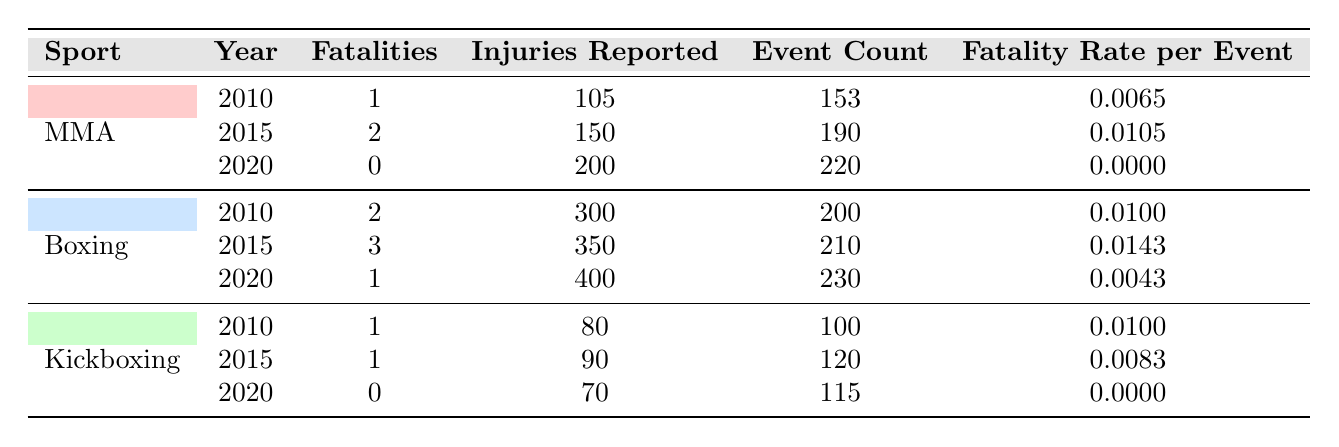What were the total fatalities in MMA between 2010 and 2020? Adding up the fatalities for the years 2010 (1), 2015 (2), and 2020 (0) gives a total of 3 fatalities in MMA over this period.
Answer: 3 In which year did MMA have the highest fatality rate per event? Looking at the fatality rates per event for MMA, in 2015 it was 0.0105, which is higher than the rates for 2010 (0.0065) and 2020 (0.0000). Thus, 2015 had the highest fatality rate.
Answer: 2015 Did boxing have more injury-related fatalities than MMA in 2010? In 2010, boxing had 2 fatalities while MMA had 1 fatality. Therefore, yes, boxing had more fatalities than MMA in 2010.
Answer: Yes What is the average fatality rate per event for kickboxing across the three years? The fatality rates per event for kickboxing are: 0.0100 for 2010, 0.0083 for 2015, and 0.0000 for 2020. The average is calculated as (0.0100 + 0.0083 + 0.0000) / 3 = 0.0061.
Answer: 0.0061 In which sport and year was the lowest number of fatalities recorded? The lowest number of fatalities recorded was 0, which occurred in both MMA in 2020 and kickboxing in 2020.
Answer: MMA and Kickboxing in 2020 What is the total number of injuries reported in boxing from 2010 to 2020? Summing the injuries reported in boxing: 300 (2010) + 350 (2015) + 400 (2020) = 1050 injuries reported in total.
Answer: 1050 Which sport had a total of 2 fatalities in the year 2015? In 2015, boxing had 3 fatalities while MMA had 2 fatalities. Hence, MMA had a total of 2 fatalities that year.
Answer: MMA Was the fatality rate per event in boxing lower than that in MMA in 2020? The fatality rate per event for boxing in 2020 was 0.0043 and for MMA it was 0.0000. Since 0.0000 is lower, the fatality rate in boxing is not lower than MMA; it's actually higher.
Answer: No 